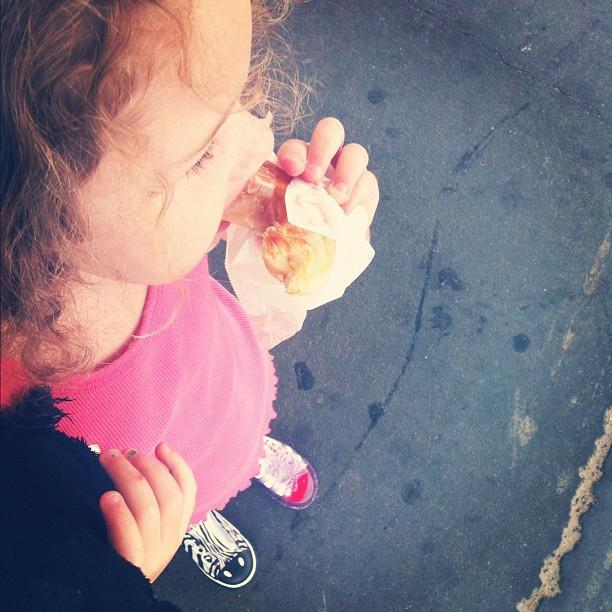What color is one of the girl's shoes? black 